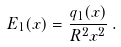<formula> <loc_0><loc_0><loc_500><loc_500>E _ { 1 } ( x ) = \frac { q _ { 1 } ( x ) } { R ^ { 2 } x ^ { 2 } } \, .</formula> 